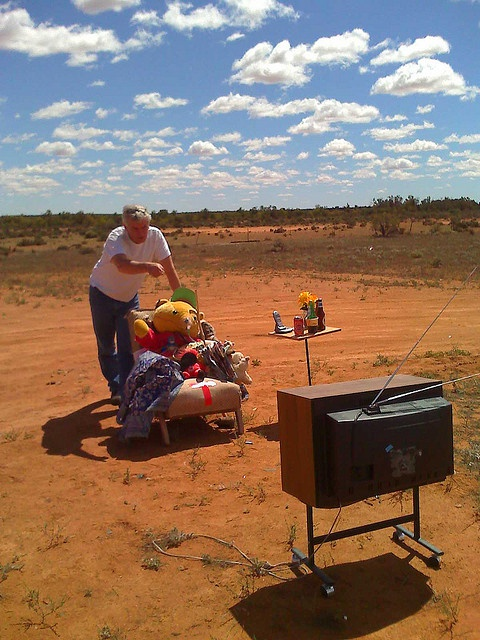Describe the objects in this image and their specific colors. I can see tv in gray, black, maroon, and tan tones, people in gray, black, brown, and maroon tones, chair in gray, maroon, black, and brown tones, teddy bear in gray, maroon, black, and brown tones, and bottle in gray, black, brown, maroon, and darkgreen tones in this image. 